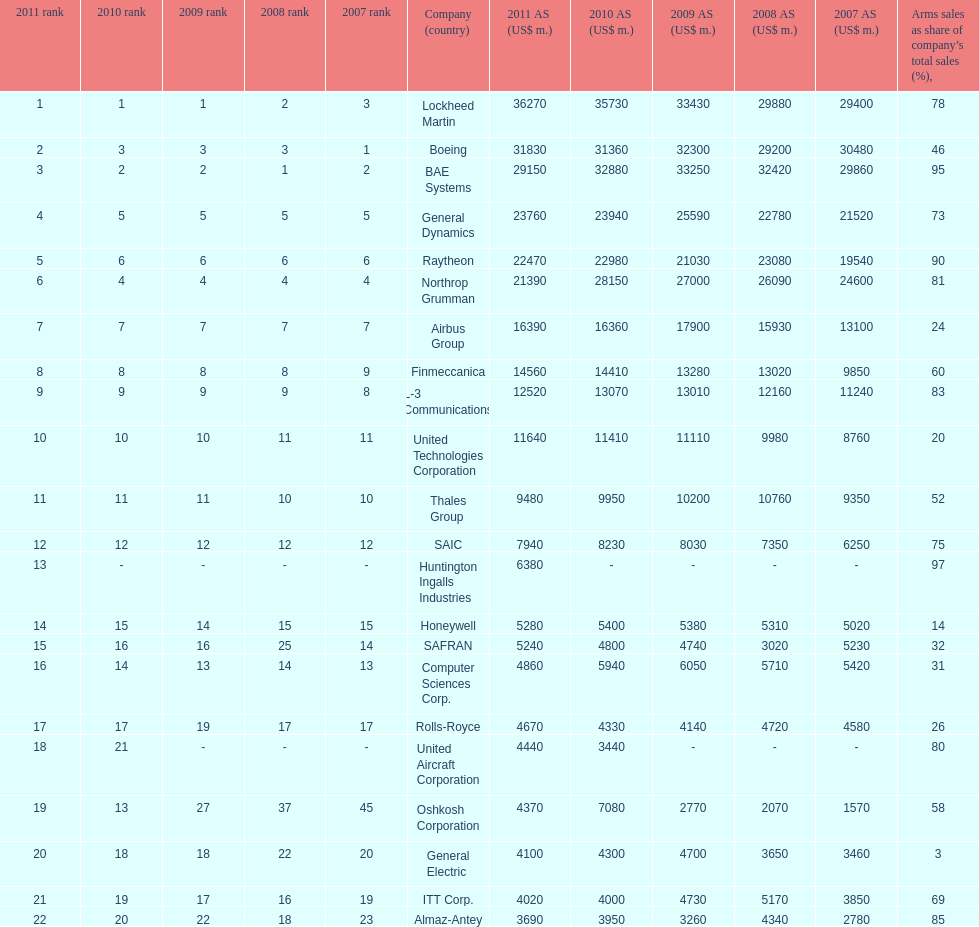Calculate the difference between boeing's 2010 arms sales and raytheon's 2010 arms sales. 8380. 